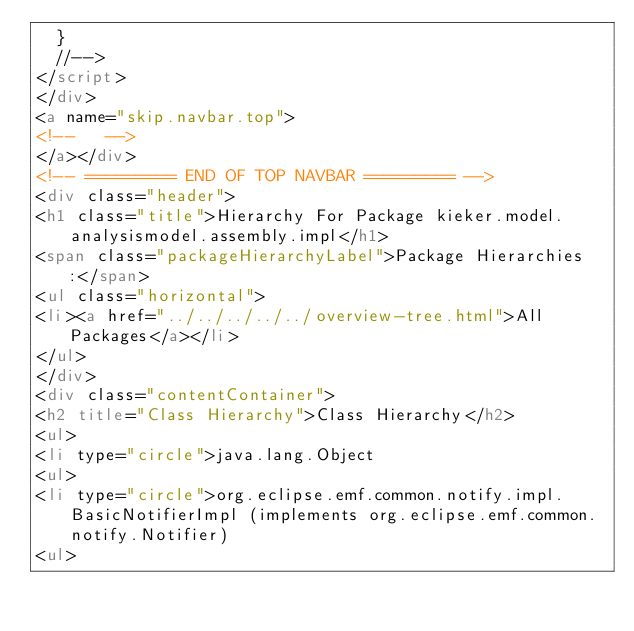<code> <loc_0><loc_0><loc_500><loc_500><_HTML_>  }
  //-->
</script>
</div>
<a name="skip.navbar.top">
<!--   -->
</a></div>
<!-- ========= END OF TOP NAVBAR ========= -->
<div class="header">
<h1 class="title">Hierarchy For Package kieker.model.analysismodel.assembly.impl</h1>
<span class="packageHierarchyLabel">Package Hierarchies:</span>
<ul class="horizontal">
<li><a href="../../../../../overview-tree.html">All Packages</a></li>
</ul>
</div>
<div class="contentContainer">
<h2 title="Class Hierarchy">Class Hierarchy</h2>
<ul>
<li type="circle">java.lang.Object
<ul>
<li type="circle">org.eclipse.emf.common.notify.impl.BasicNotifierImpl (implements org.eclipse.emf.common.notify.Notifier)
<ul></code> 